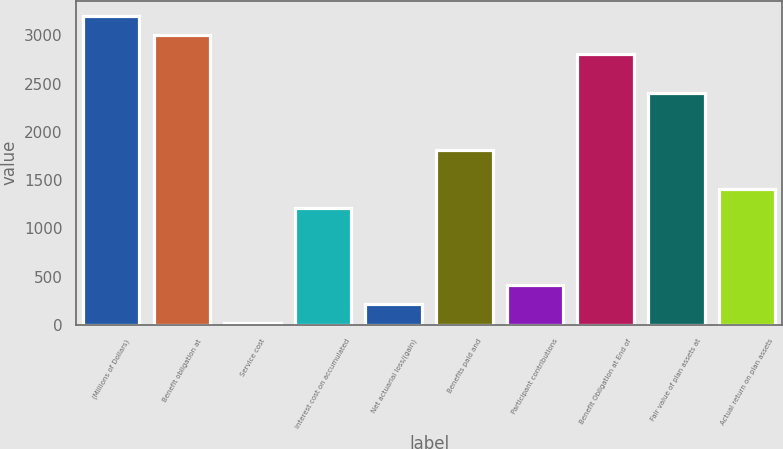Convert chart to OTSL. <chart><loc_0><loc_0><loc_500><loc_500><bar_chart><fcel>(Millions of Dollars)<fcel>Benefit obligation at<fcel>Service cost<fcel>Interest cost on accumulated<fcel>Net actuarial loss/(gain)<fcel>Benefits paid and<fcel>Participant contributions<fcel>Benefit Obligation at End of<fcel>Fair value of plan assets at<fcel>Actual return on plan assets<nl><fcel>3199.4<fcel>3000.5<fcel>17<fcel>1210.4<fcel>215.9<fcel>1807.1<fcel>414.8<fcel>2801.6<fcel>2403.8<fcel>1409.3<nl></chart> 